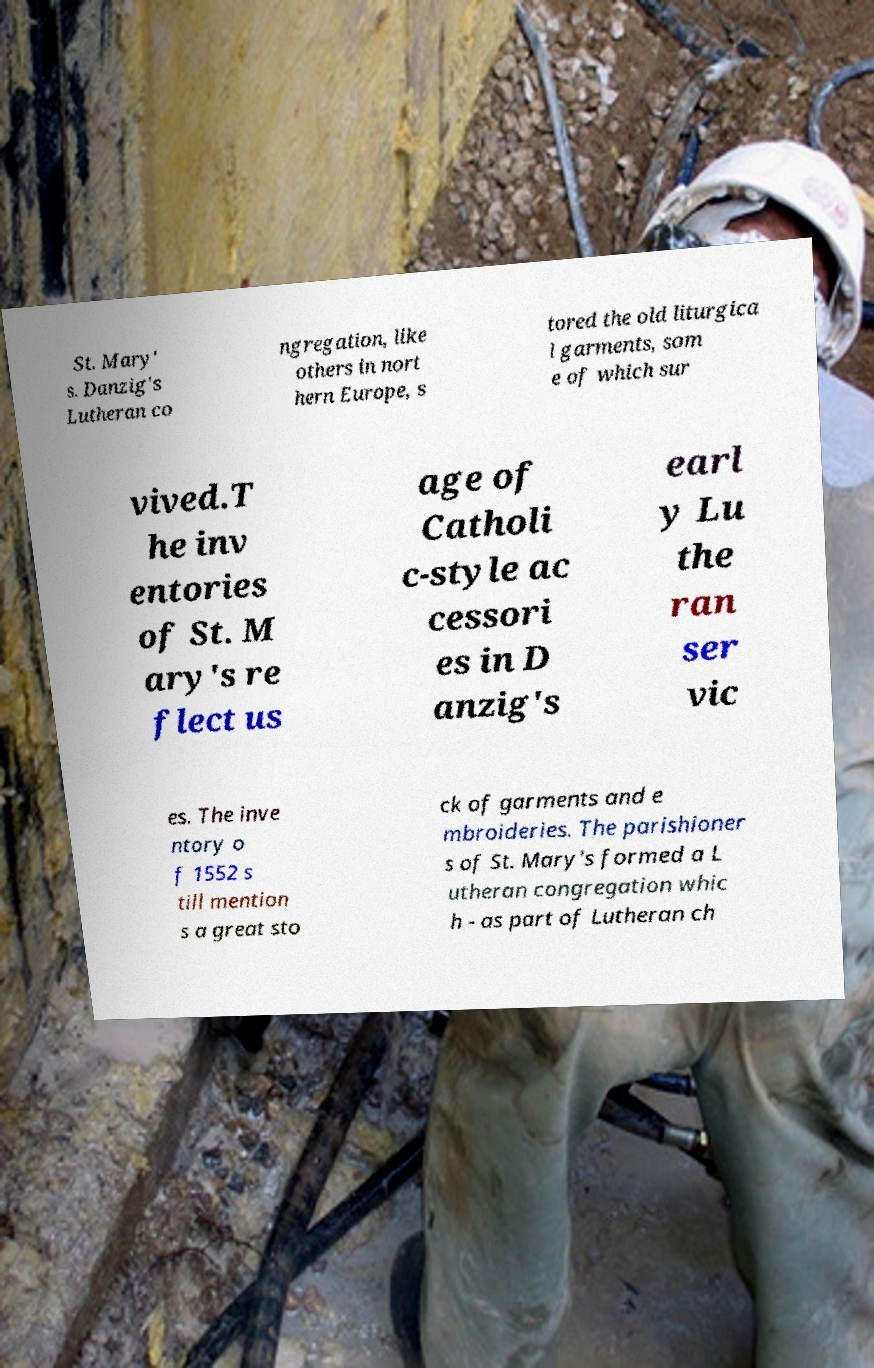Could you assist in decoding the text presented in this image and type it out clearly? St. Mary' s. Danzig's Lutheran co ngregation, like others in nort hern Europe, s tored the old liturgica l garments, som e of which sur vived.T he inv entories of St. M ary's re flect us age of Catholi c-style ac cessori es in D anzig's earl y Lu the ran ser vic es. The inve ntory o f 1552 s till mention s a great sto ck of garments and e mbroideries. The parishioner s of St. Mary's formed a L utheran congregation whic h - as part of Lutheran ch 